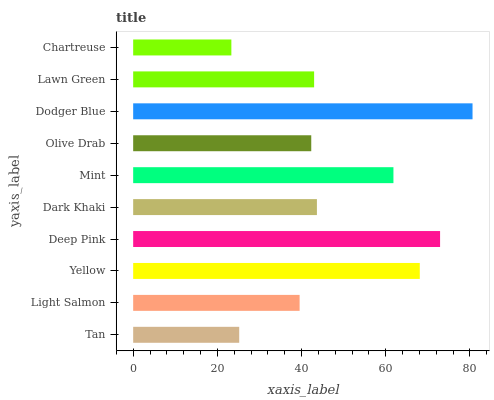Is Chartreuse the minimum?
Answer yes or no. Yes. Is Dodger Blue the maximum?
Answer yes or no. Yes. Is Light Salmon the minimum?
Answer yes or no. No. Is Light Salmon the maximum?
Answer yes or no. No. Is Light Salmon greater than Tan?
Answer yes or no. Yes. Is Tan less than Light Salmon?
Answer yes or no. Yes. Is Tan greater than Light Salmon?
Answer yes or no. No. Is Light Salmon less than Tan?
Answer yes or no. No. Is Dark Khaki the high median?
Answer yes or no. Yes. Is Lawn Green the low median?
Answer yes or no. Yes. Is Tan the high median?
Answer yes or no. No. Is Yellow the low median?
Answer yes or no. No. 